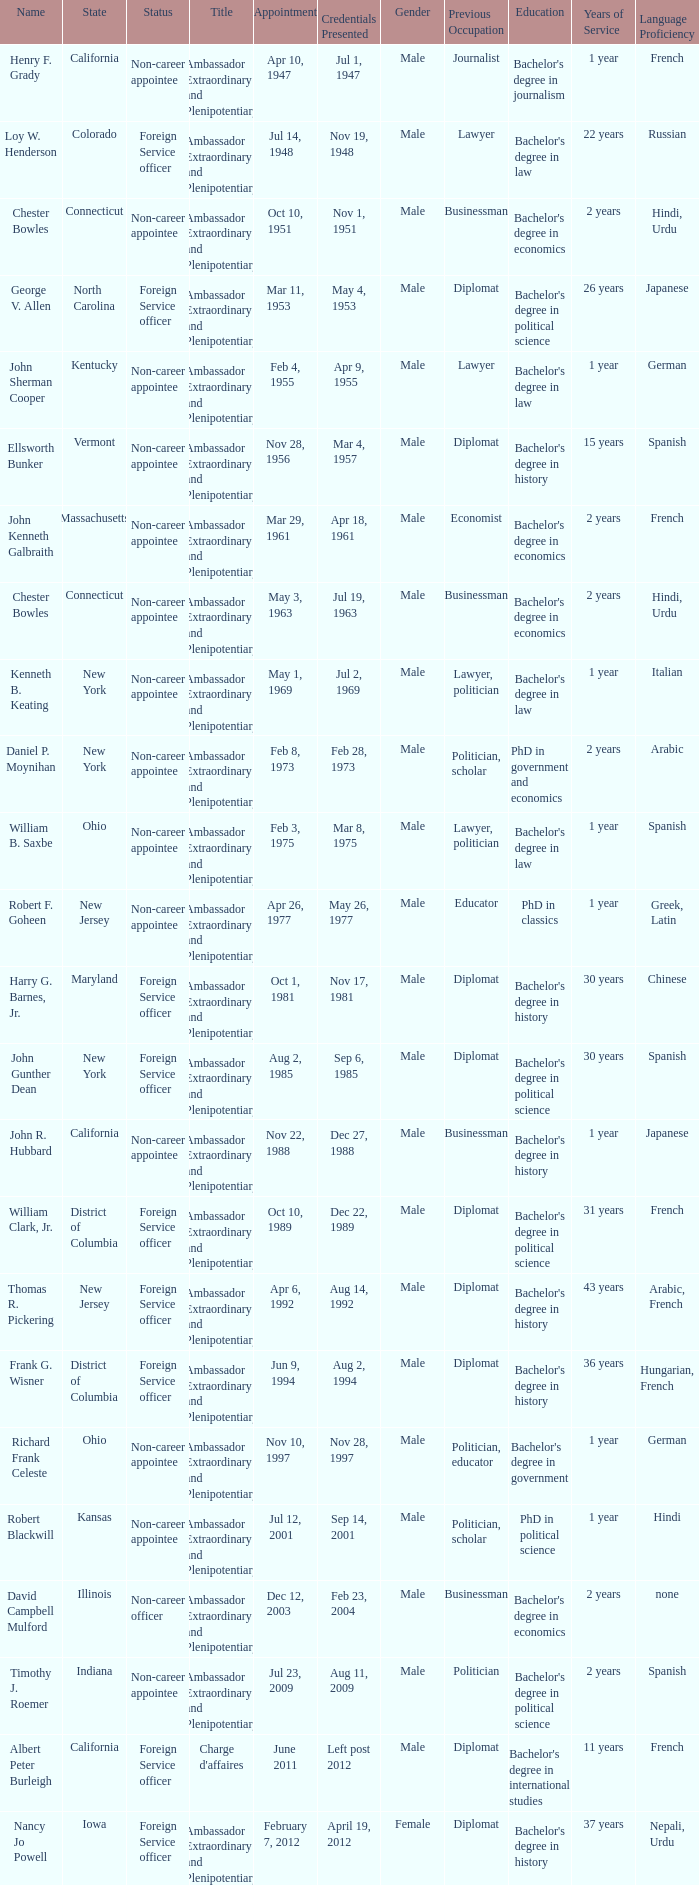What is the title for david campbell mulford? Ambassador Extraordinary and Plenipotentiary. 